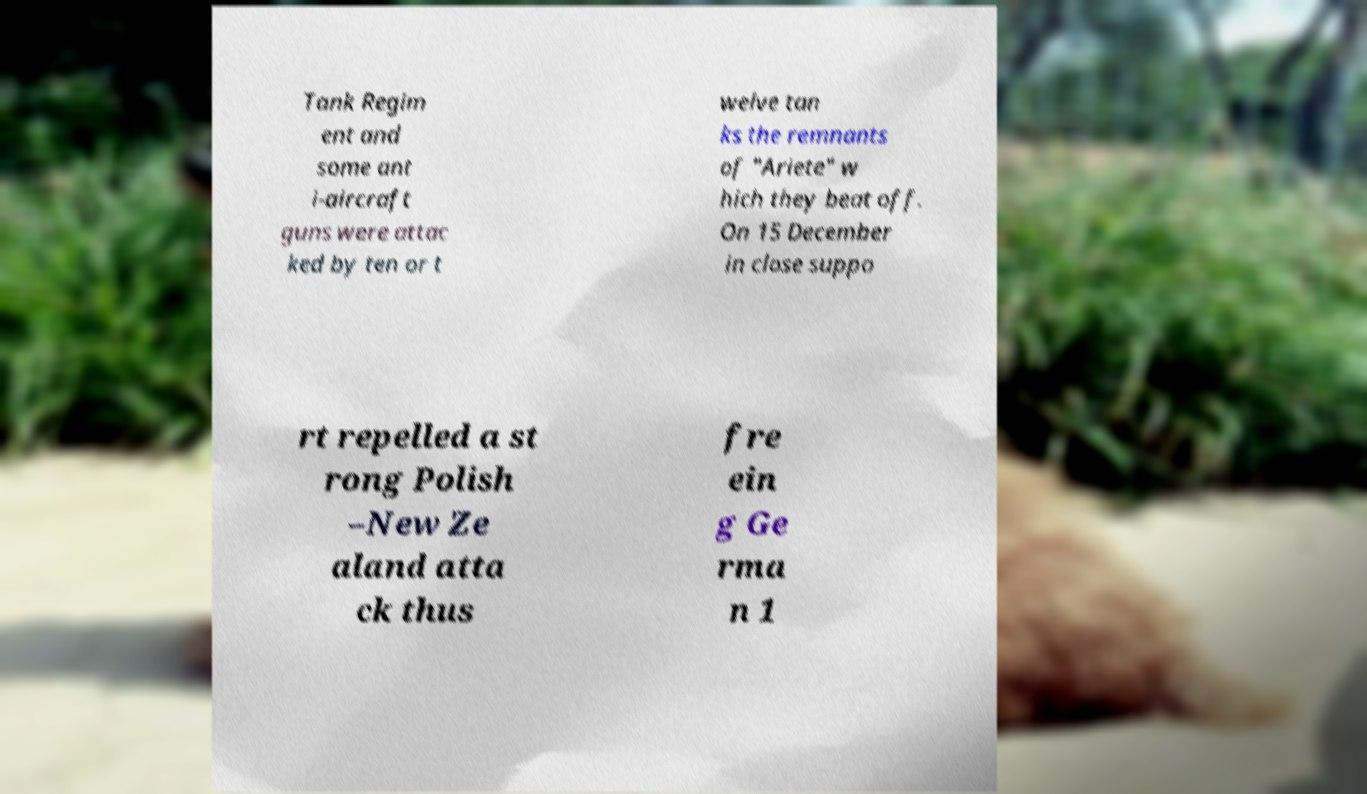For documentation purposes, I need the text within this image transcribed. Could you provide that? Tank Regim ent and some ant i-aircraft guns were attac ked by ten or t welve tan ks the remnants of "Ariete" w hich they beat off. On 15 December in close suppo rt repelled a st rong Polish –New Ze aland atta ck thus fre ein g Ge rma n 1 